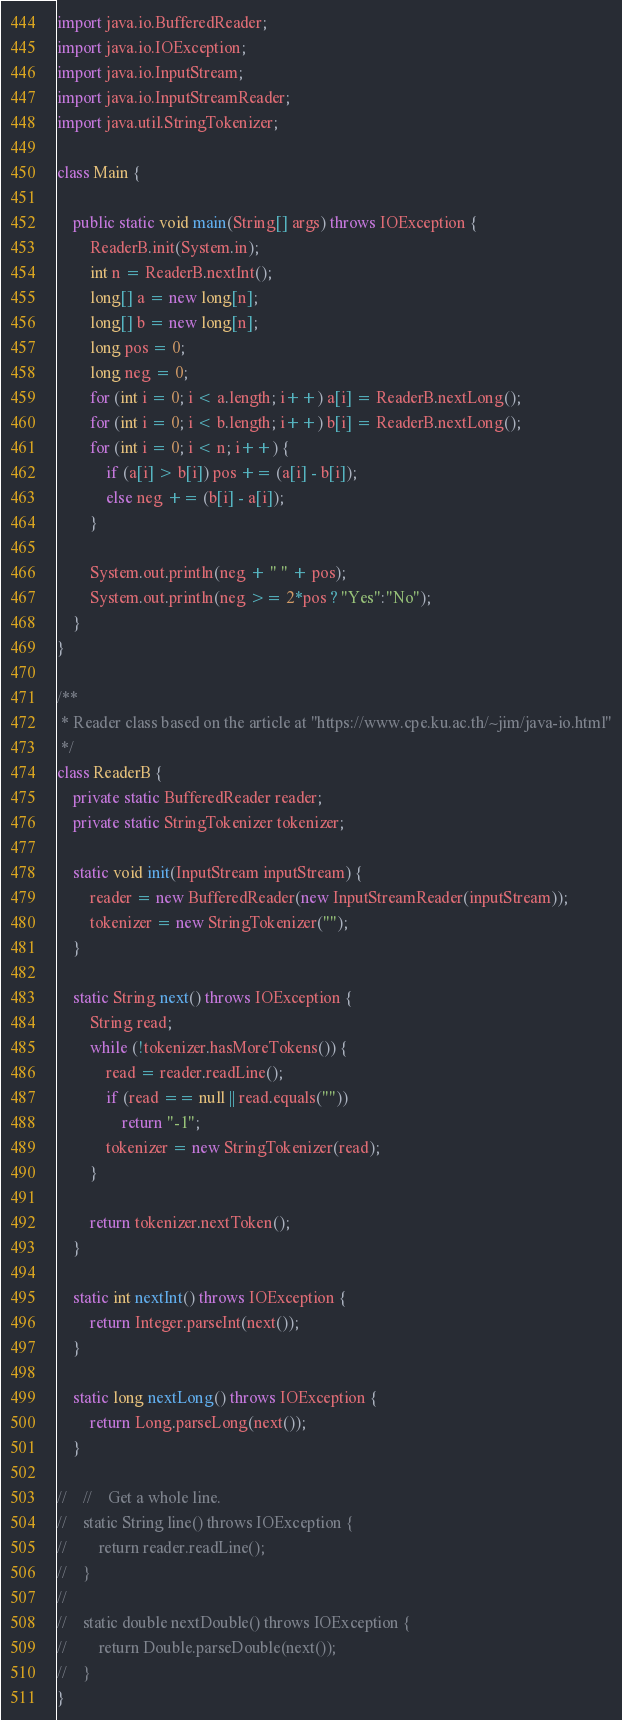<code> <loc_0><loc_0><loc_500><loc_500><_Java_>import java.io.BufferedReader;
import java.io.IOException;
import java.io.InputStream;
import java.io.InputStreamReader;
import java.util.StringTokenizer;

class Main {

    public static void main(String[] args) throws IOException {
        ReaderB.init(System.in);
        int n = ReaderB.nextInt();
        long[] a = new long[n];
        long[] b = new long[n];
        long pos = 0;
        long neg = 0;
        for (int i = 0; i < a.length; i++) a[i] = ReaderB.nextLong();
        for (int i = 0; i < b.length; i++) b[i] = ReaderB.nextLong();
        for (int i = 0; i < n; i++) {
            if (a[i] > b[i]) pos += (a[i] - b[i]);
            else neg += (b[i] - a[i]);
        }

        System.out.println(neg + " " + pos);
        System.out.println(neg >= 2*pos ? "Yes":"No");
    }
}

/**
 * Reader class based on the article at "https://www.cpe.ku.ac.th/~jim/java-io.html"
 */
class ReaderB {
    private static BufferedReader reader;
    private static StringTokenizer tokenizer;

    static void init(InputStream inputStream) {
        reader = new BufferedReader(new InputStreamReader(inputStream));
        tokenizer = new StringTokenizer("");
    }

    static String next() throws IOException {
        String read;
        while (!tokenizer.hasMoreTokens()) {
            read = reader.readLine();
            if (read == null || read.equals(""))
                return "-1";
            tokenizer = new StringTokenizer(read);
        }

        return tokenizer.nextToken();
    }

    static int nextInt() throws IOException {
        return Integer.parseInt(next());
    }

    static long nextLong() throws IOException {
        return Long.parseLong(next());
    }

//    //    Get a whole line.
//    static String line() throws IOException {
//        return reader.readLine();
//    }
//
//    static double nextDouble() throws IOException {
//        return Double.parseDouble(next());
//    }
}

</code> 